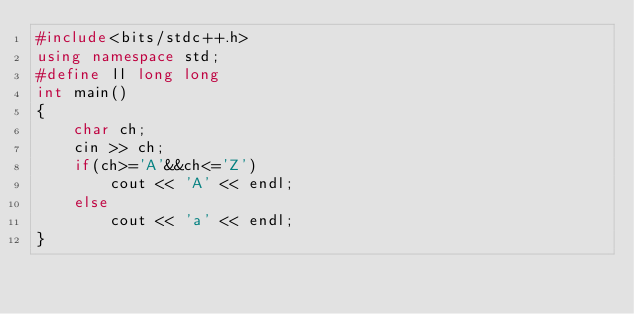Convert code to text. <code><loc_0><loc_0><loc_500><loc_500><_C++_>#include<bits/stdc++.h>
using namespace std;
#define ll long long
int main()
{
    char ch;
    cin >> ch;
    if(ch>='A'&&ch<='Z')
        cout << 'A' << endl;
    else
        cout << 'a' << endl;
}
</code> 